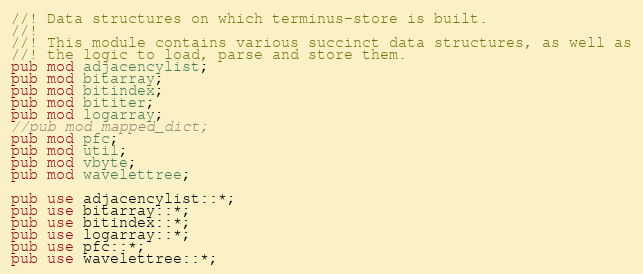<code> <loc_0><loc_0><loc_500><loc_500><_Rust_>//! Data structures on which terminus-store is built.
//!
//! This module contains various succinct data structures, as well as
//! the logic to load, parse and store them.
pub mod adjacencylist;
pub mod bitarray;
pub mod bitindex;
pub mod bititer;
pub mod logarray;
//pub mod mapped_dict;
pub mod pfc;
pub mod util;
pub mod vbyte;
pub mod wavelettree;

pub use adjacencylist::*;
pub use bitarray::*;
pub use bitindex::*;
pub use logarray::*;
pub use pfc::*;
pub use wavelettree::*;
</code> 